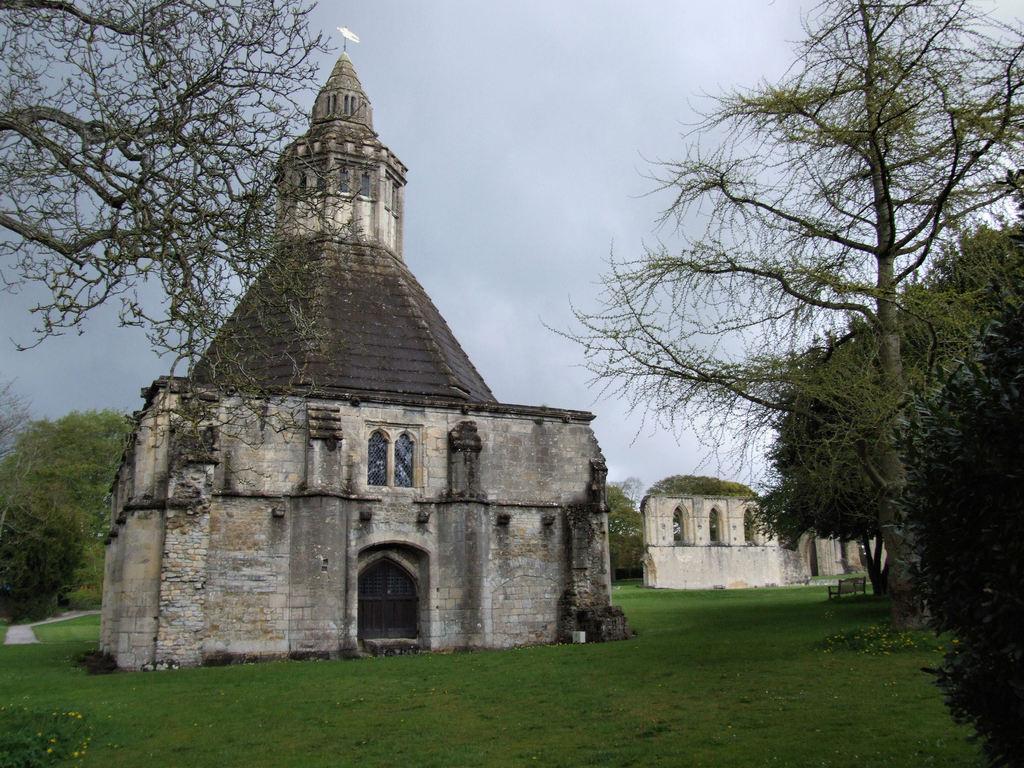How would you summarize this image in a sentence or two? This looks like a building with a window and a door. I think this is a spire. These are the trees with branches and leaves. Here is a grass. This looks like a bench, which is under the tree. I think this is a pathway. 